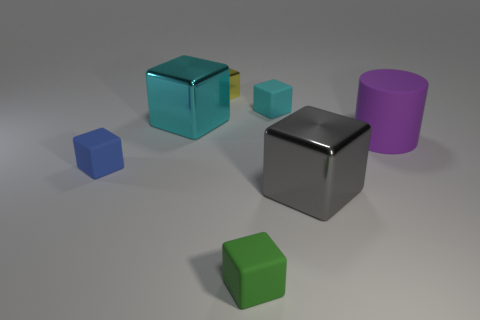Subtract 4 blocks. How many blocks are left? 2 Subtract all blue blocks. How many blocks are left? 5 Subtract all big cyan cubes. How many cubes are left? 5 Subtract all cyan cubes. Subtract all brown cylinders. How many cubes are left? 4 Add 1 small cyan matte objects. How many objects exist? 8 Subtract all blocks. How many objects are left? 1 Add 1 blue objects. How many blue objects exist? 2 Subtract 0 brown blocks. How many objects are left? 7 Subtract all small cyan spheres. Subtract all small matte cubes. How many objects are left? 4 Add 2 rubber things. How many rubber things are left? 6 